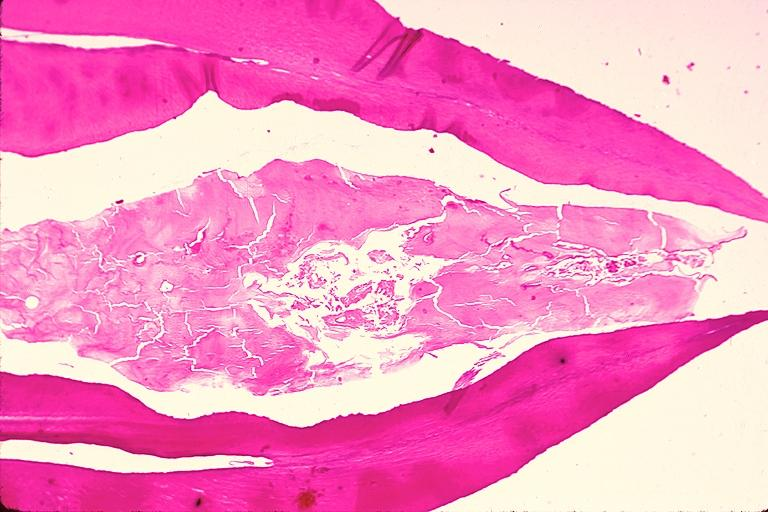what is present?
Answer the question using a single word or phrase. Oral 